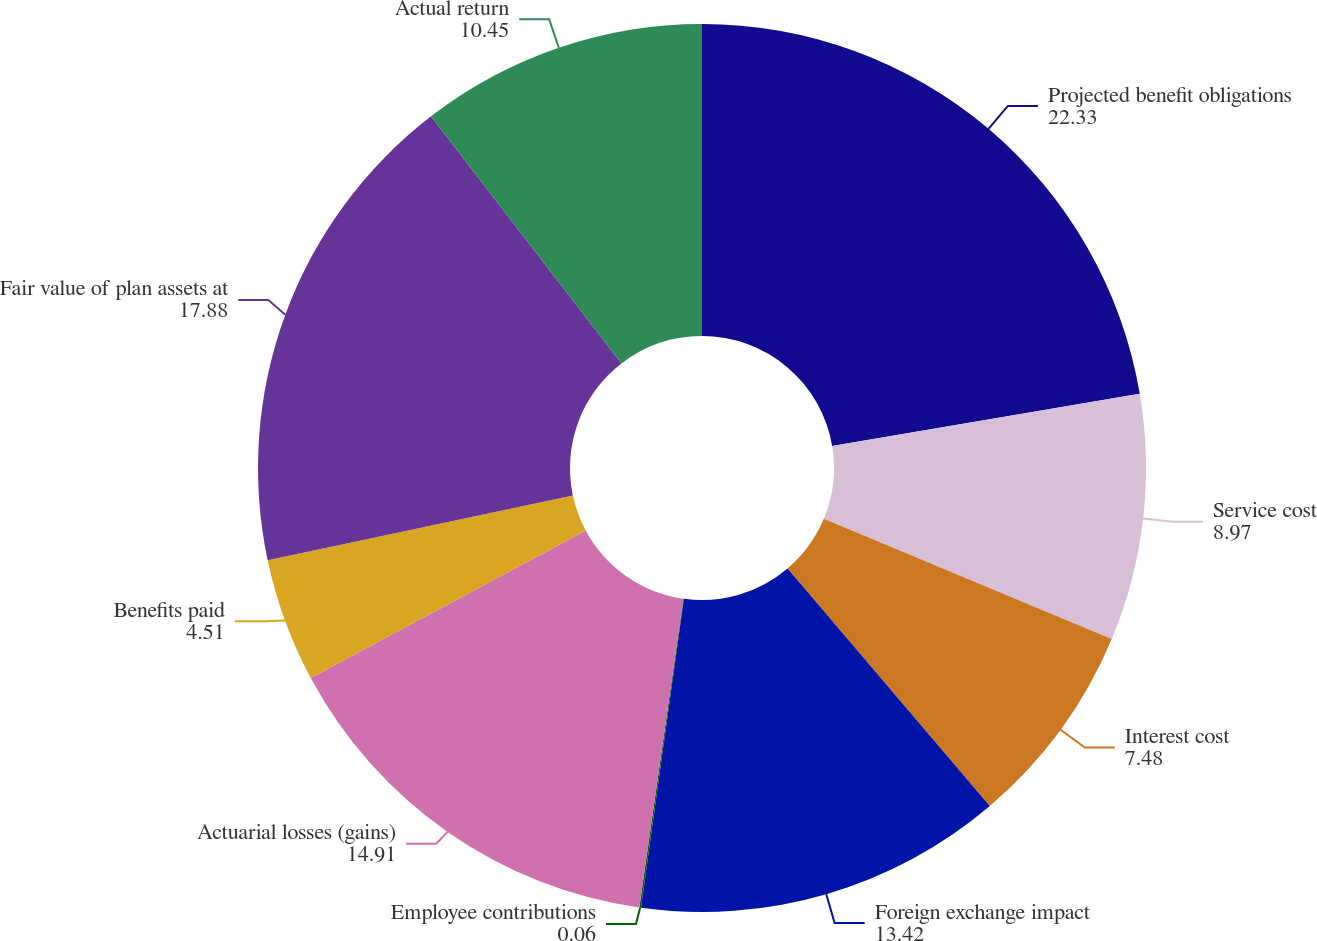<chart> <loc_0><loc_0><loc_500><loc_500><pie_chart><fcel>Projected benefit obligations<fcel>Service cost<fcel>Interest cost<fcel>Foreign exchange impact<fcel>Employee contributions<fcel>Actuarial losses (gains)<fcel>Benefits paid<fcel>Fair value of plan assets at<fcel>Actual return<nl><fcel>22.33%<fcel>8.97%<fcel>7.48%<fcel>13.42%<fcel>0.06%<fcel>14.91%<fcel>4.51%<fcel>17.88%<fcel>10.45%<nl></chart> 